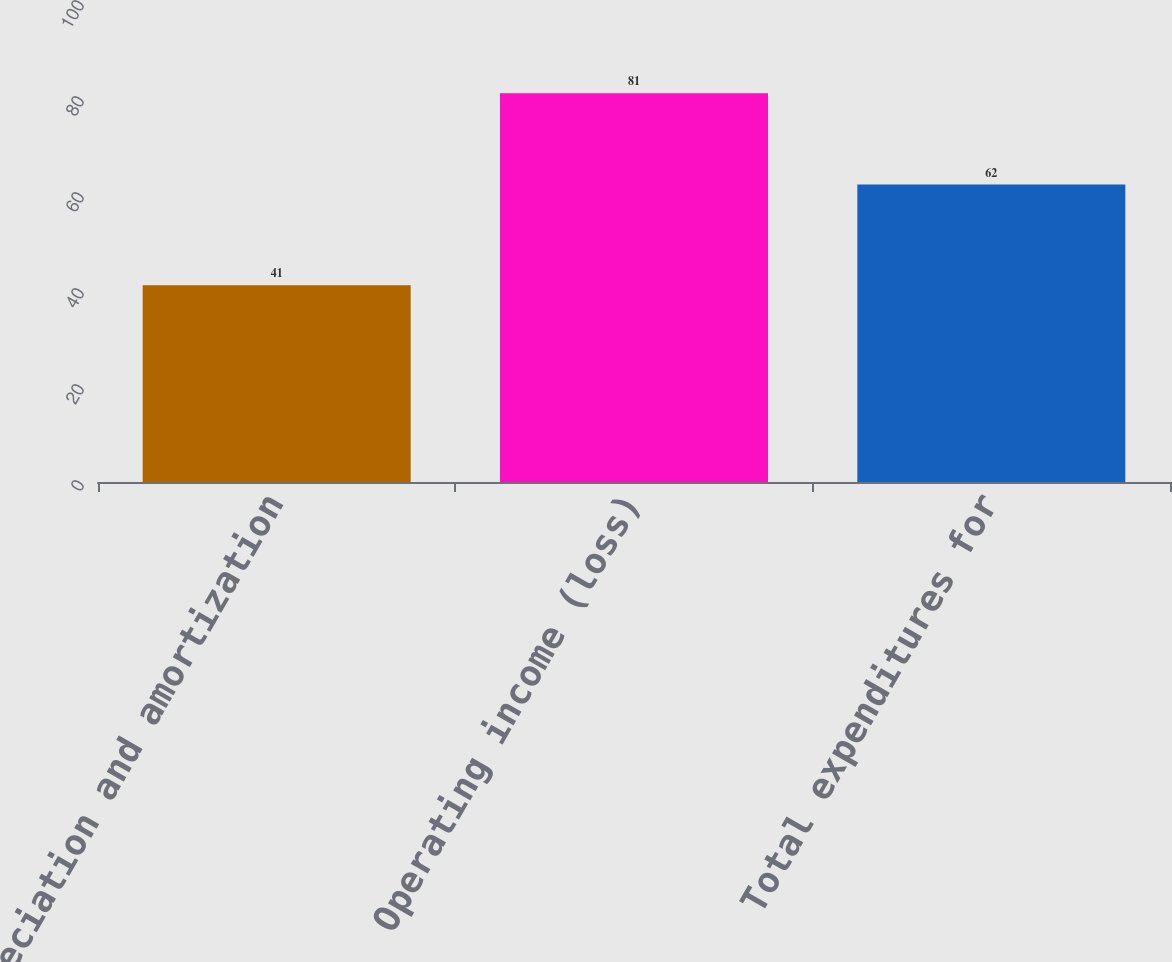Convert chart. <chart><loc_0><loc_0><loc_500><loc_500><bar_chart><fcel>Depreciation and amortization<fcel>Operating income (loss)<fcel>Total expenditures for<nl><fcel>41<fcel>81<fcel>62<nl></chart> 